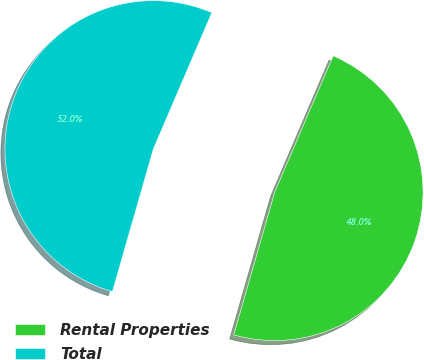Convert chart to OTSL. <chart><loc_0><loc_0><loc_500><loc_500><pie_chart><fcel>Rental Properties<fcel>Total<nl><fcel>48.0%<fcel>52.0%<nl></chart> 